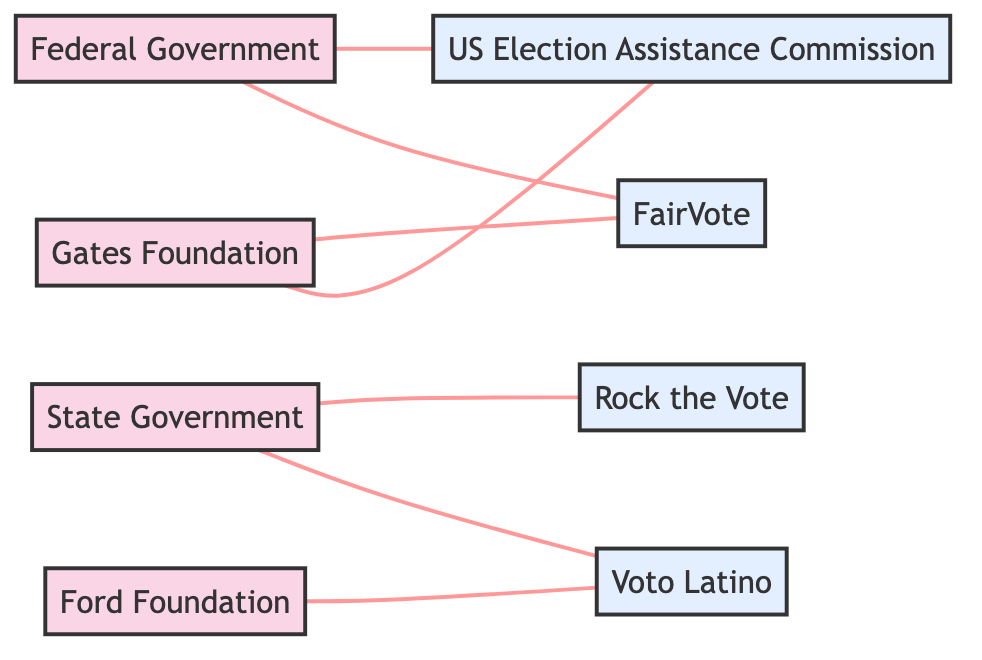What are the funding sources in this diagram? The diagram contains four funding sources: "Federal Government," "State Government," "Ford Foundation," and "Bill & Melinda Gates Foundation."
Answer: Federal Government, State Government, Ford Foundation, Bill & Melinda Gates Foundation Which voter outreach program is funded by the Federal Government? The diagram shows that the "US Election Assistance Commission" and "FairVote" are both funded by the Federal Government.
Answer: US Election Assistance Commission, FairVote How many edges are present in the graph? By counting the connections (edges) that represent funding relationships, there are a total of six edges in the diagram.
Answer: 6 Which foundations provide funding to FairVote? The diagram indicates that "FairVote" receives funding from both the "Bill & Melinda Gates Foundation" and the "Federal Government."
Answer: Bill & Melinda Gates Foundation, Federal Government Which voter outreach program is exclusively supported by private funding? The diagram shows that "Voto Latino" receives funding from private sources such as the "Ford Foundation" and the "State Government," and is not funded by the Federal Government. Therefore, it solely relies on these private sources.
Answer: Voto Latino How many voter outreach programs are funded by the State Government? The diagram indicates that the State Government provides funding to "Rock the Vote" and "Voto Latino," showing a total of two outreach programs are funded by the State Government.
Answer: 2 Which funding source connects to the US Election Assistance Commission? The diagram shows that both the "Federal Government" and the "Bill & Melinda Gates Foundation" connect to the "US Election Assistance Commission" as funding sources.
Answer: Federal Government, Bill & Melinda Gates Foundation What is the relationship between the State Government and Voto Latino? The diagram specifies that the State Government "funds" Voto Latino, establishing a direct financial relationship between the two.
Answer: funds What type of diagram is represented here? This is an undirected graph, as it visually represents the flow of funds between different sources and programs without a specific directionality.
Answer: Undirected Graph 